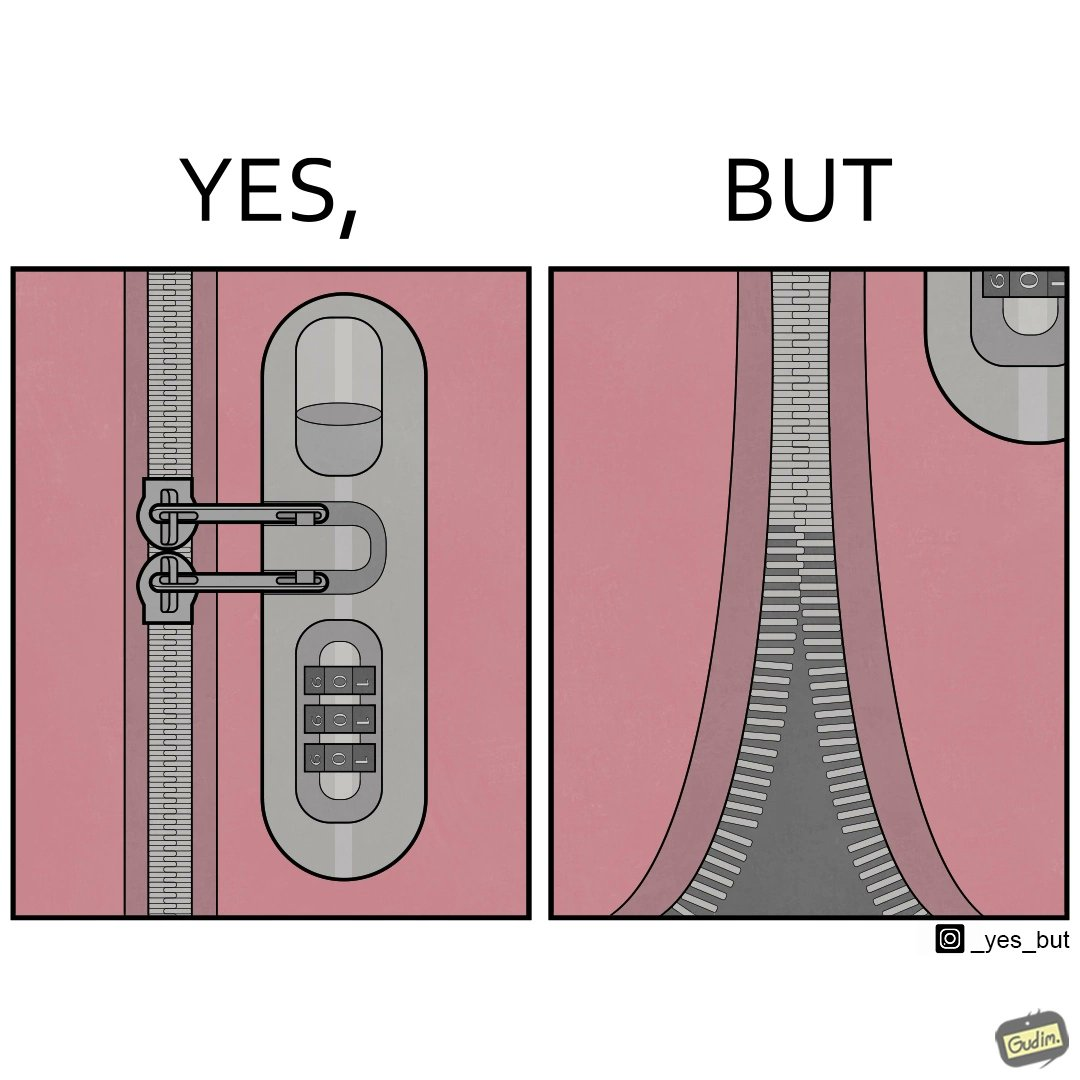Is this a satirical image? Yes, this image is satirical. 